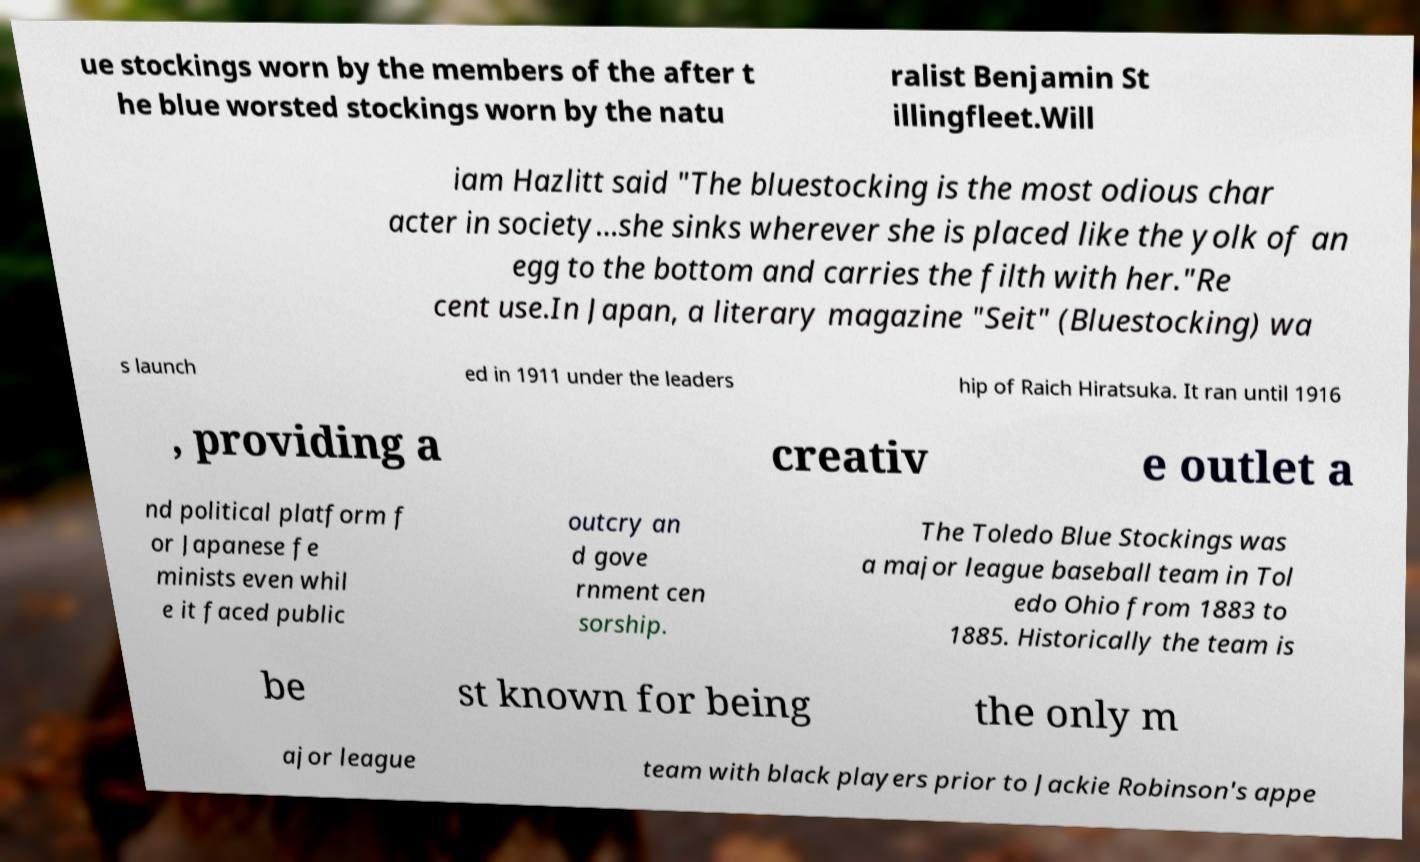Please read and relay the text visible in this image. What does it say? ue stockings worn by the members of the after t he blue worsted stockings worn by the natu ralist Benjamin St illingfleet.Will iam Hazlitt said "The bluestocking is the most odious char acter in society...she sinks wherever she is placed like the yolk of an egg to the bottom and carries the filth with her."Re cent use.In Japan, a literary magazine "Seit" (Bluestocking) wa s launch ed in 1911 under the leaders hip of Raich Hiratsuka. It ran until 1916 , providing a creativ e outlet a nd political platform f or Japanese fe minists even whil e it faced public outcry an d gove rnment cen sorship. The Toledo Blue Stockings was a major league baseball team in Tol edo Ohio from 1883 to 1885. Historically the team is be st known for being the only m ajor league team with black players prior to Jackie Robinson's appe 